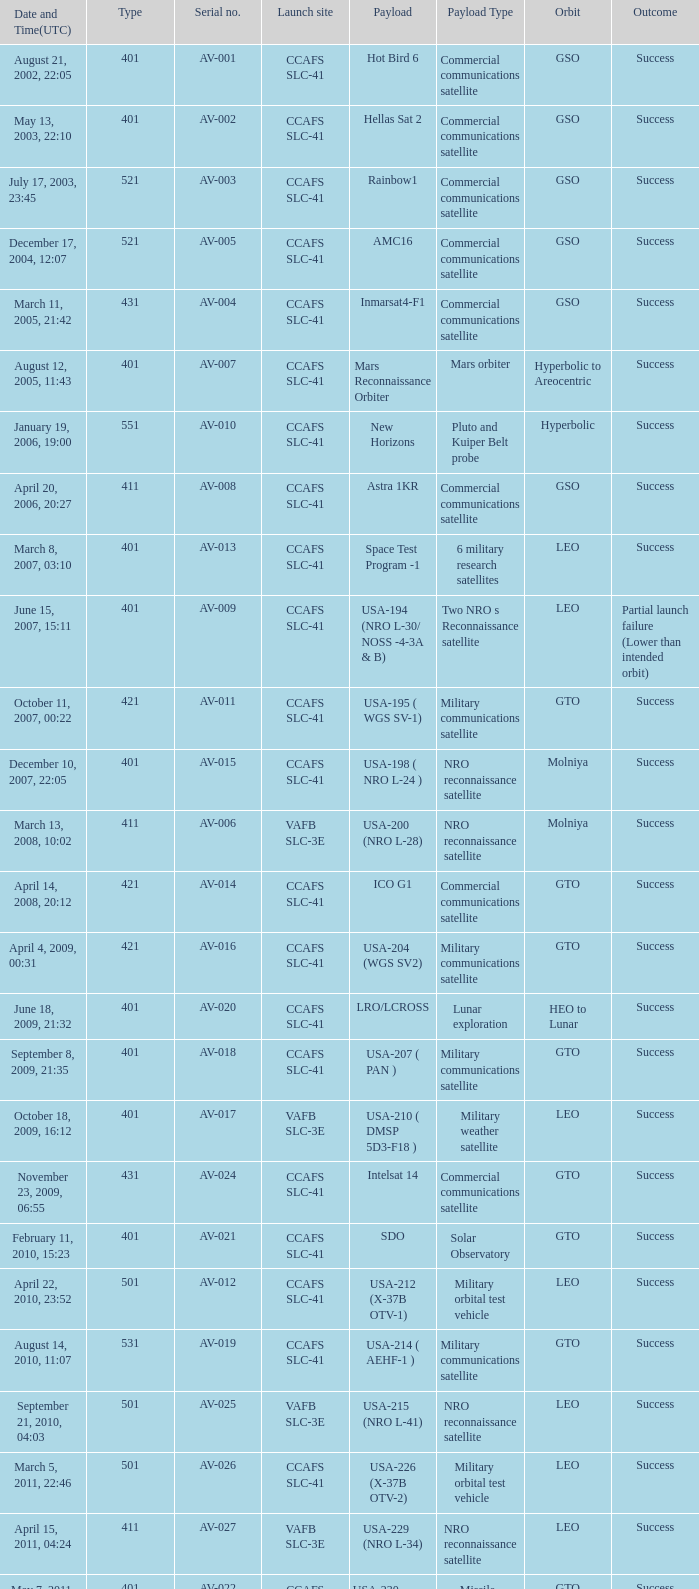For the payload of Van Allen Belts Exploration what's the serial number? AV-032. 